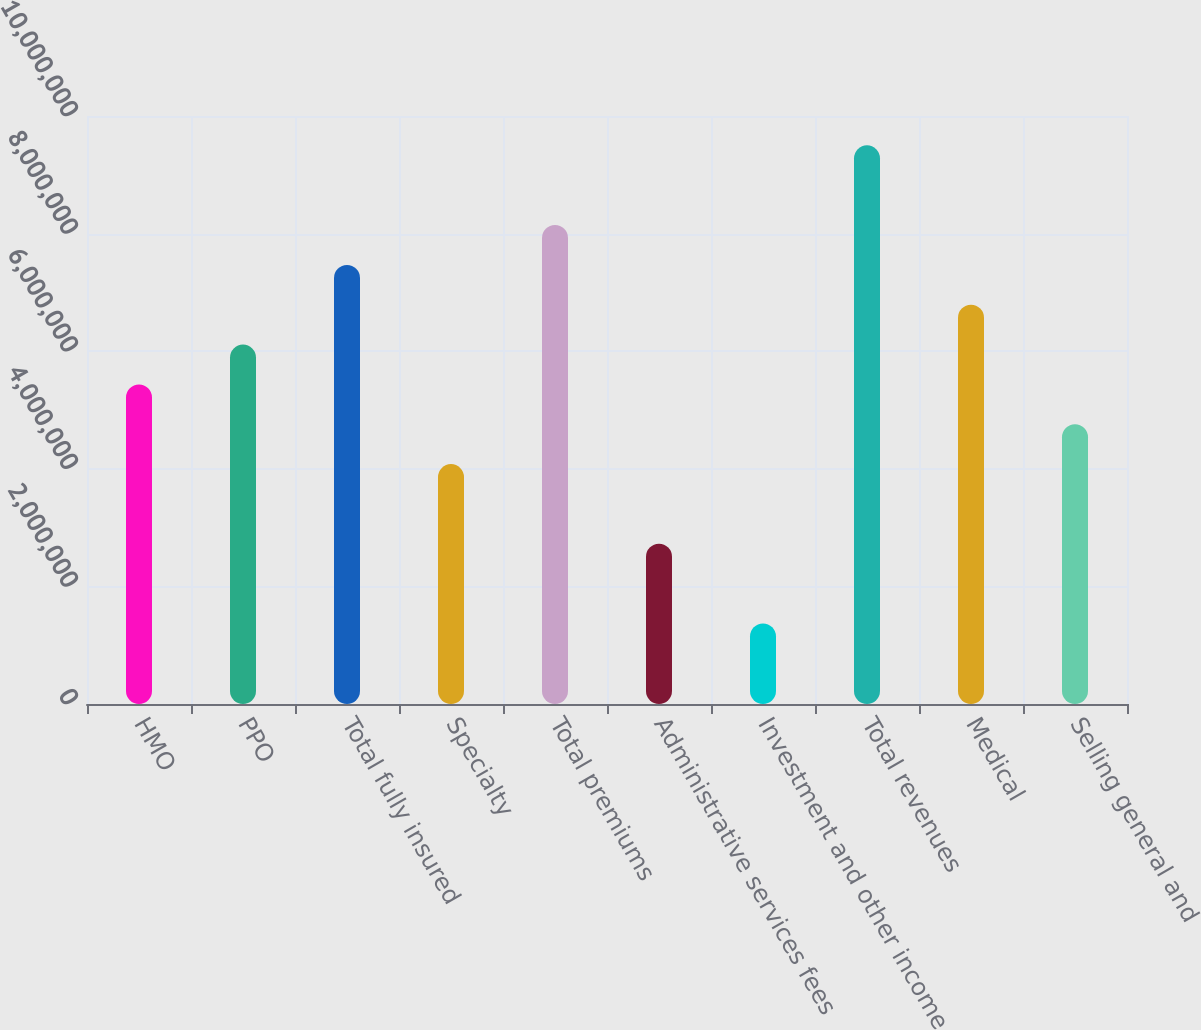Convert chart. <chart><loc_0><loc_0><loc_500><loc_500><bar_chart><fcel>HMO<fcel>PPO<fcel>Total fully insured<fcel>Specialty<fcel>Total premiums<fcel>Administrative services fees<fcel>Investment and other income<fcel>Total revenues<fcel>Medical<fcel>Selling general and<nl><fcel>5.43513e+06<fcel>6.11275e+06<fcel>7.46799e+06<fcel>4.07988e+06<fcel>8.14561e+06<fcel>2.72464e+06<fcel>1.3694e+06<fcel>9.50086e+06<fcel>6.79037e+06<fcel>4.75751e+06<nl></chart> 